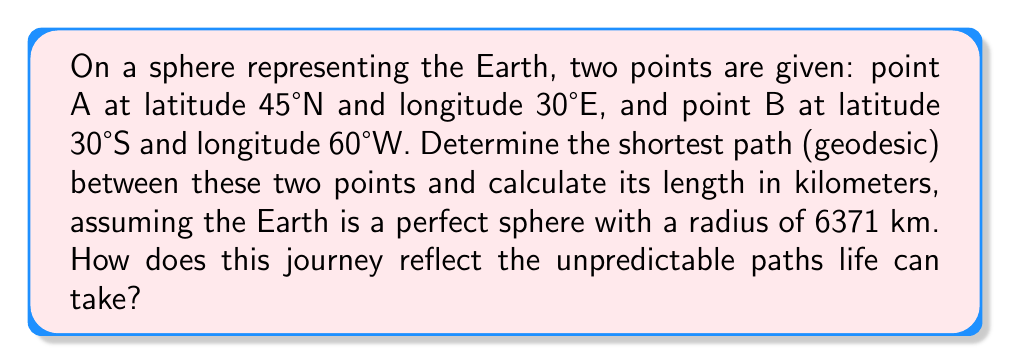Can you answer this question? To find the shortest path (geodesic) between two points on a sphere and calculate its length, we'll use the great circle distance formula. This method involves the following steps:

1. Convert the given coordinates to radians:
   $\phi_1 = 45° \cdot \frac{\pi}{180} = 0.7854$ rad (latitude A)
   $\lambda_1 = 30° \cdot \frac{\pi}{180} = 0.5236$ rad (longitude A)
   $\phi_2 = -30° \cdot \frac{\pi}{180} = -0.5236$ rad (latitude B)
   $\lambda_2 = -60° \cdot \frac{\pi}{180} = -1.0472$ rad (longitude B)

2. Calculate the central angle $\Delta\sigma$ using the Haversine formula:
   $$\Delta\sigma = 2 \arcsin\left(\sqrt{\sin^2\left(\frac{\phi_2 - \phi_1}{2}\right) + \cos\phi_1 \cos\phi_2 \sin^2\left(\frac{\lambda_2 - \lambda_1}{2}\right)}\right)$$

3. Substitute the values:
   $$\Delta\sigma = 2 \arcsin\left(\sqrt{\sin^2\left(\frac{-0.5236 - 0.7854}{2}\right) + \cos(0.7854) \cos(-0.5236) \sin^2\left(\frac{-1.0472 - 0.5236}{2}\right)}\right)$$

4. Evaluate:
   $\Delta\sigma \approx 2.0944$ radians

5. Calculate the great circle distance $d$:
   $d = R \cdot \Delta\sigma$
   Where $R$ is the radius of the Earth (6371 km)
   $d = 6371 \cdot 2.0944 \approx 13,345$ km

The shortest path between the two points is the great circle arc connecting them, which follows the curve of the sphere's surface. This geodesic represents the most efficient route, much like how we often seek the most direct path through life's challenges. However, just as the Earth's surface isn't perfectly spherical, life's journey is rarely as straightforward as we might hope, reminding us of the unexpected turns and obstacles we may encounter along the way.
Answer: 13,345 km 